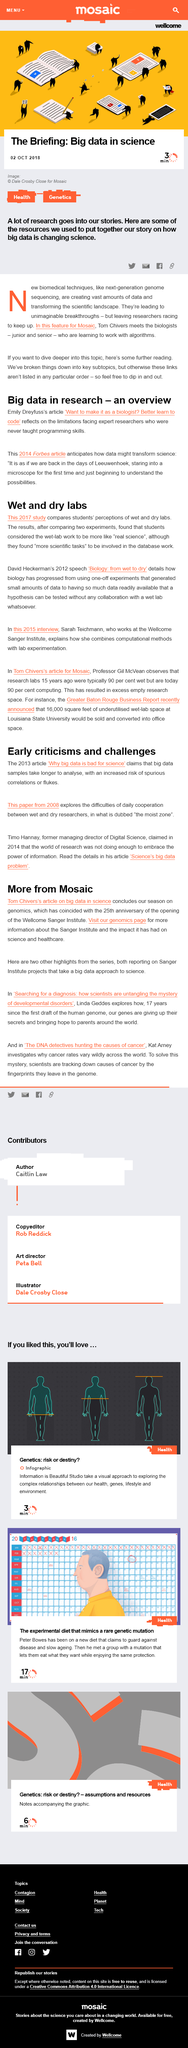Point out several critical features in this image. The article claims that analyzing big data samples takes longer than analyzing smaller data samples. A lot of research goes into creating stories. The Sanger Institute is currently investigating the mystery of developmental disorders as one of its projects. The article on big data in science was published on October 2nd, 2018. In 2014, the Forbes article was published. 